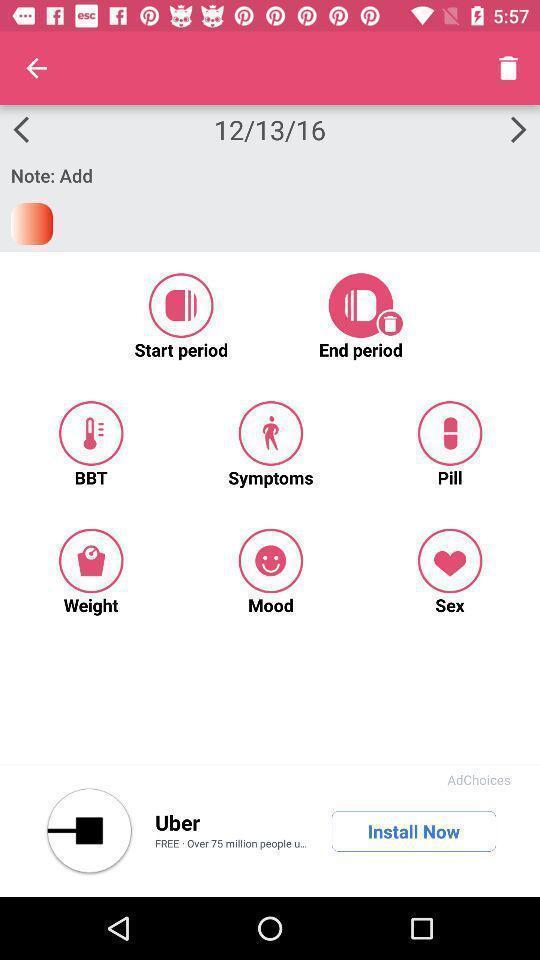What can you discern from this picture? Screen displaying multiple options in a fertility tracking application. 